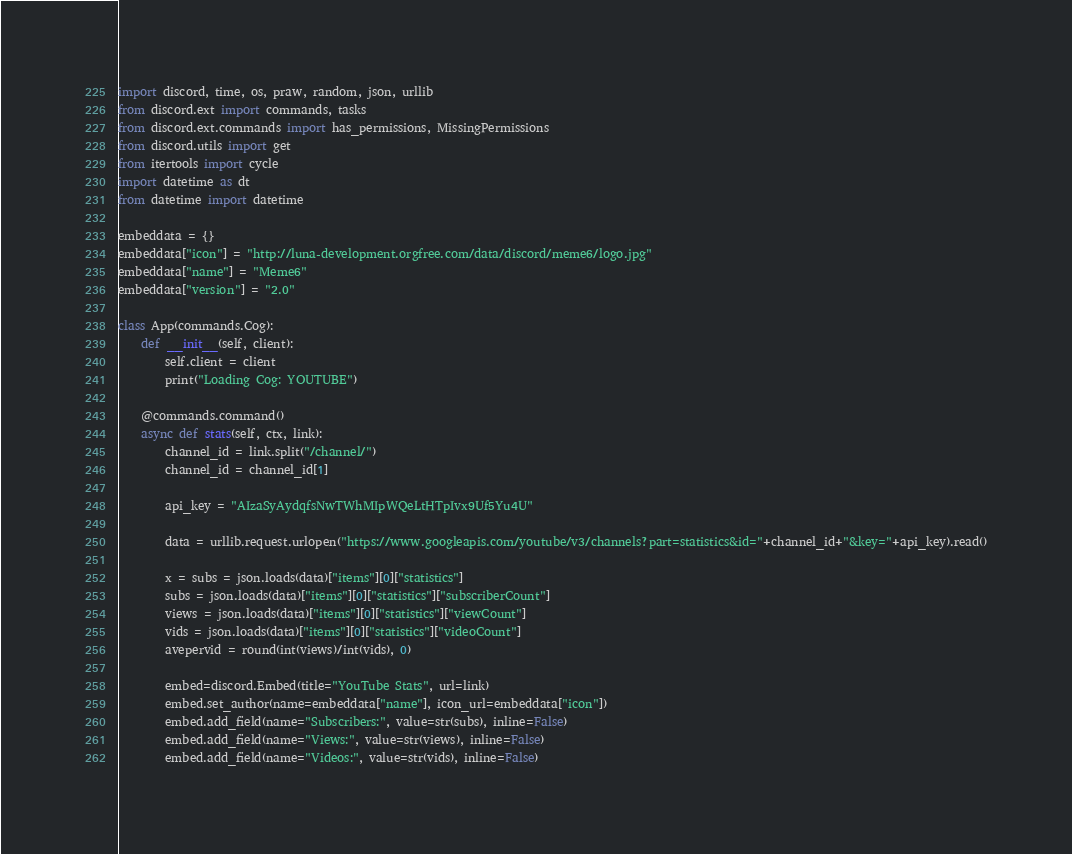<code> <loc_0><loc_0><loc_500><loc_500><_Python_>import discord, time, os, praw, random, json, urllib
from discord.ext import commands, tasks
from discord.ext.commands import has_permissions, MissingPermissions
from discord.utils import get
from itertools import cycle
import datetime as dt
from datetime import datetime

embeddata = {}
embeddata["icon"] = "http://luna-development.orgfree.com/data/discord/meme6/logo.jpg"
embeddata["name"] = "Meme6"
embeddata["version"] = "2.0"

class App(commands.Cog):
    def __init__(self, client):
        self.client = client
        print("Loading Cog: YOUTUBE")

    @commands.command()
    async def stats(self, ctx, link):
        channel_id = link.split("/channel/")
        channel_id = channel_id[1]

        api_key = "AIzaSyAydqfsNwTWhMIpWQeLtHTpIvx9Uf5Yu4U"

        data = urllib.request.urlopen("https://www.googleapis.com/youtube/v3/channels?part=statistics&id="+channel_id+"&key="+api_key).read()

        x = subs = json.loads(data)["items"][0]["statistics"]
        subs = json.loads(data)["items"][0]["statistics"]["subscriberCount"]
        views = json.loads(data)["items"][0]["statistics"]["viewCount"]
        vids = json.loads(data)["items"][0]["statistics"]["videoCount"]
        avepervid = round(int(views)/int(vids), 0)

        embed=discord.Embed(title="YouTube Stats", url=link)
        embed.set_author(name=embeddata["name"], icon_url=embeddata["icon"])
        embed.add_field(name="Subscribers:", value=str(subs), inline=False)
        embed.add_field(name="Views:", value=str(views), inline=False)
        embed.add_field(name="Videos:", value=str(vids), inline=False)</code> 